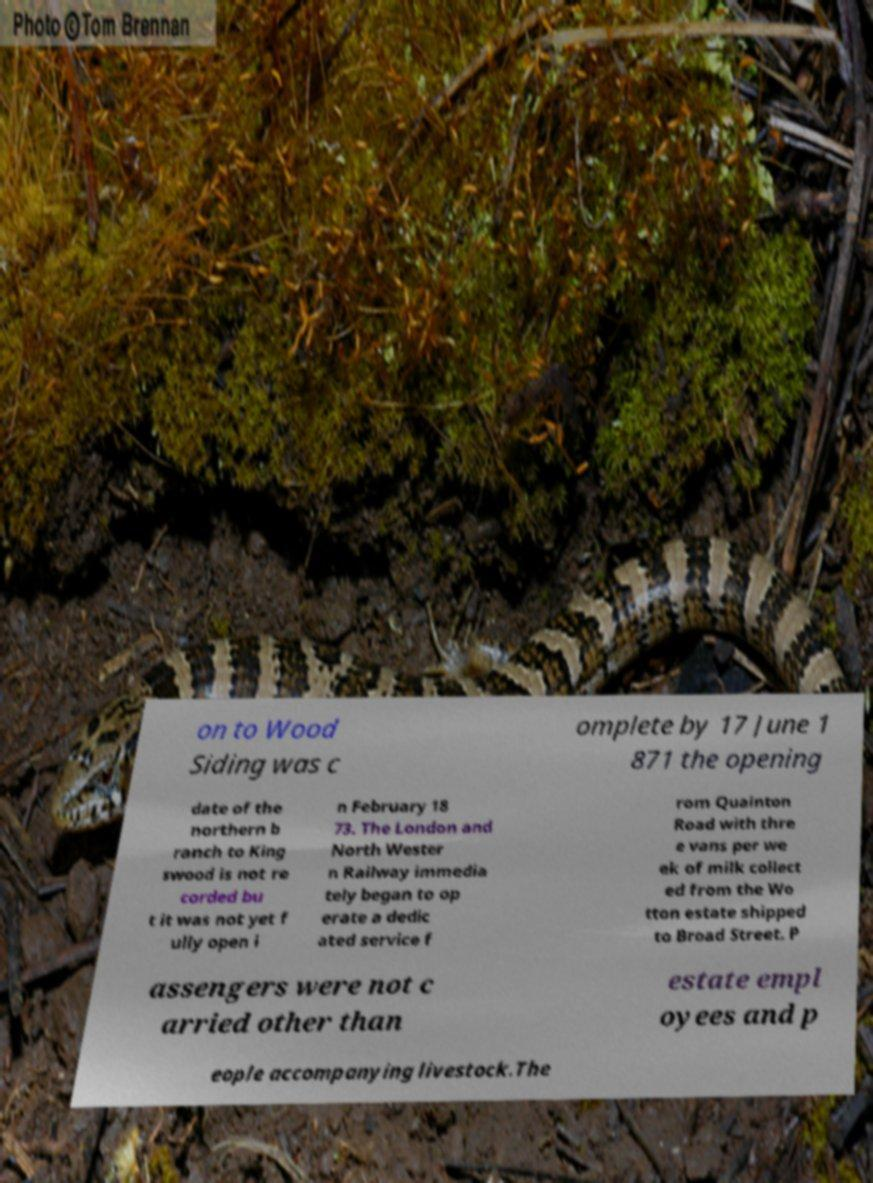Can you read and provide the text displayed in the image?This photo seems to have some interesting text. Can you extract and type it out for me? on to Wood Siding was c omplete by 17 June 1 871 the opening date of the northern b ranch to King swood is not re corded bu t it was not yet f ully open i n February 18 73. The London and North Wester n Railway immedia tely began to op erate a dedic ated service f rom Quainton Road with thre e vans per we ek of milk collect ed from the Wo tton estate shipped to Broad Street. P assengers were not c arried other than estate empl oyees and p eople accompanying livestock.The 